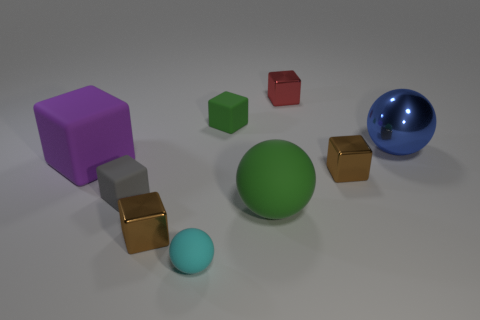The tiny rubber thing that is the same color as the large rubber ball is what shape?
Offer a very short reply. Cube. Are there any tiny gray objects?
Ensure brevity in your answer.  Yes. The small brown metallic object on the left side of the small red metal thing has what shape?
Make the answer very short. Cube. What number of cubes are both behind the tiny green rubber object and in front of the big rubber ball?
Your answer should be very brief. 0. Is there a small thing that has the same material as the tiny cyan sphere?
Offer a terse response. Yes. What is the size of the cube that is the same color as the large matte sphere?
Your answer should be very brief. Small. How many cylinders are either gray rubber things or purple objects?
Your response must be concise. 0. What is the size of the gray block?
Your answer should be very brief. Small. There is a large purple rubber thing; what number of matte blocks are to the right of it?
Offer a terse response. 2. There is a brown object behind the tiny brown object to the left of the small red cube; what size is it?
Your response must be concise. Small. 